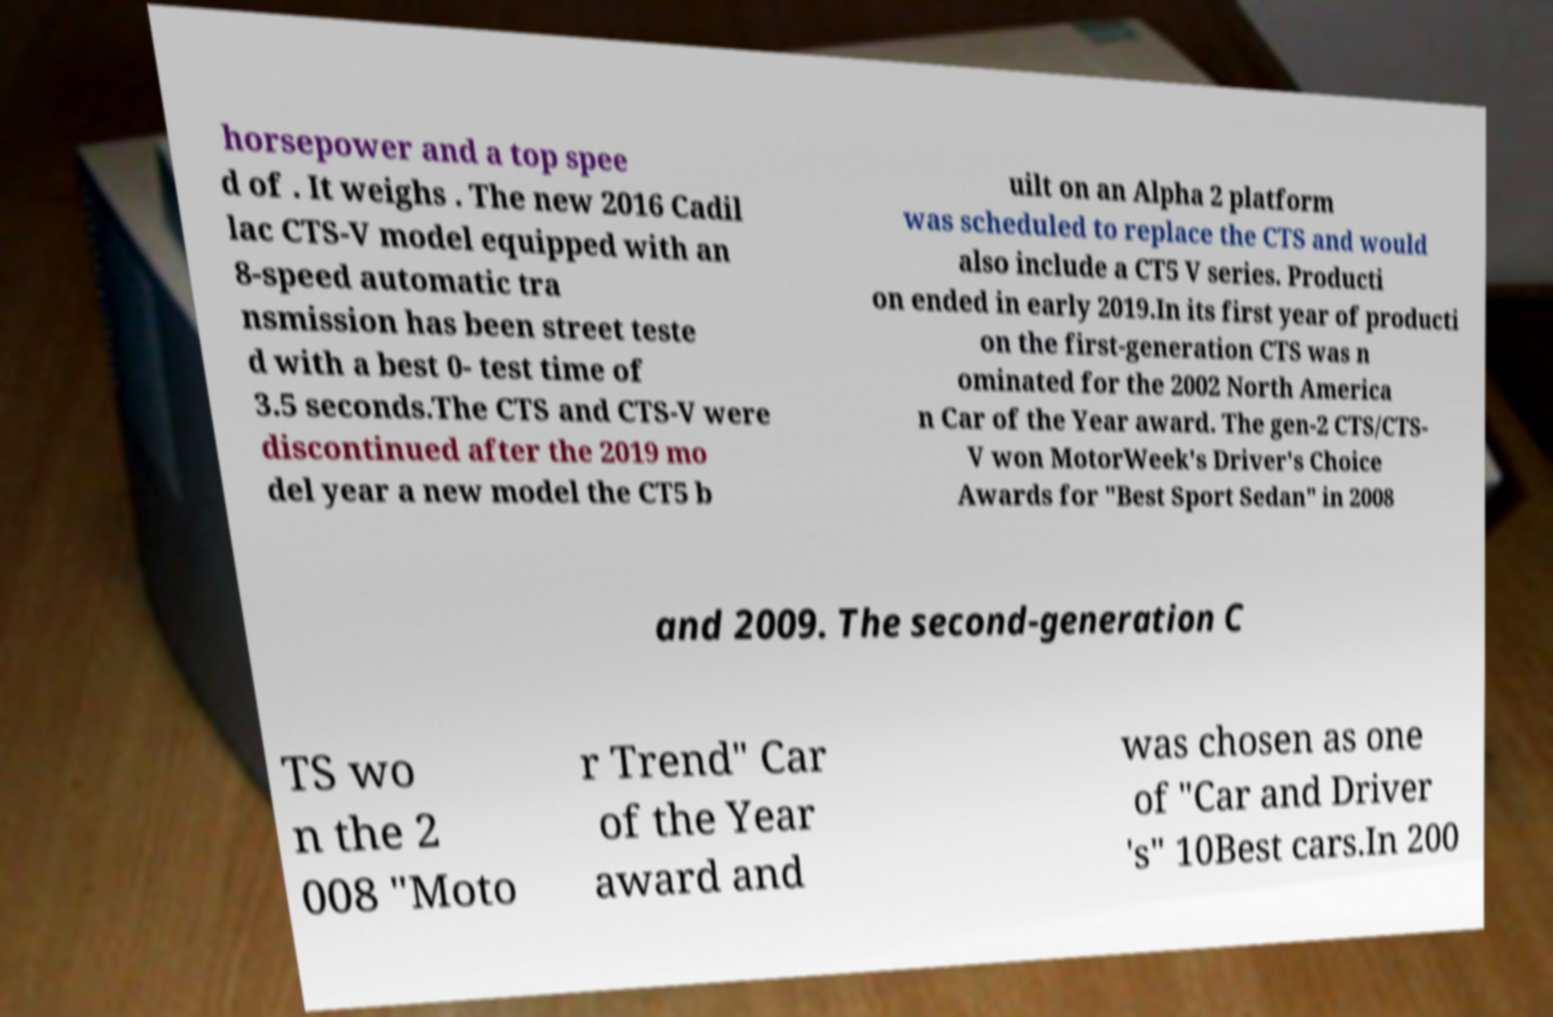Please read and relay the text visible in this image. What does it say? horsepower and a top spee d of . It weighs . The new 2016 Cadil lac CTS-V model equipped with an 8-speed automatic tra nsmission has been street teste d with a best 0- test time of 3.5 seconds.The CTS and CTS-V were discontinued after the 2019 mo del year a new model the CT5 b uilt on an Alpha 2 platform was scheduled to replace the CTS and would also include a CT5 V series. Producti on ended in early 2019.In its first year of producti on the first-generation CTS was n ominated for the 2002 North America n Car of the Year award. The gen-2 CTS/CTS- V won MotorWeek's Driver's Choice Awards for "Best Sport Sedan" in 2008 and 2009. The second-generation C TS wo n the 2 008 "Moto r Trend" Car of the Year award and was chosen as one of "Car and Driver 's" 10Best cars.In 200 